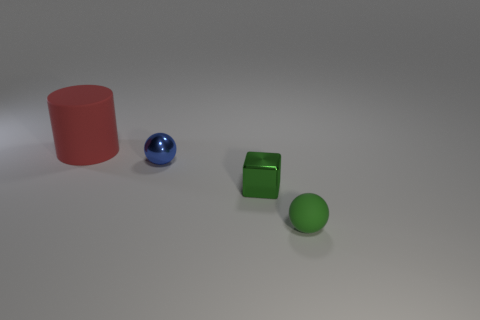Add 2 metallic blocks. How many objects exist? 6 Subtract all blue spheres. How many spheres are left? 1 Add 3 metal things. How many metal things are left? 5 Add 3 gray matte cylinders. How many gray matte cylinders exist? 3 Subtract 0 red balls. How many objects are left? 4 Subtract 1 balls. How many balls are left? 1 Subtract all brown blocks. Subtract all cyan cylinders. How many blocks are left? 1 Subtract all red balls. How many brown cylinders are left? 0 Subtract all yellow things. Subtract all green things. How many objects are left? 2 